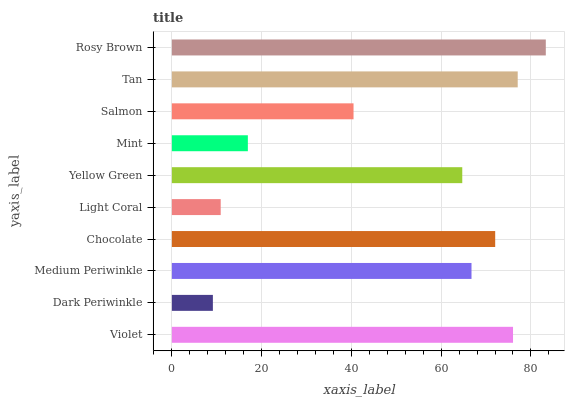Is Dark Periwinkle the minimum?
Answer yes or no. Yes. Is Rosy Brown the maximum?
Answer yes or no. Yes. Is Medium Periwinkle the minimum?
Answer yes or no. No. Is Medium Periwinkle the maximum?
Answer yes or no. No. Is Medium Periwinkle greater than Dark Periwinkle?
Answer yes or no. Yes. Is Dark Periwinkle less than Medium Periwinkle?
Answer yes or no. Yes. Is Dark Periwinkle greater than Medium Periwinkle?
Answer yes or no. No. Is Medium Periwinkle less than Dark Periwinkle?
Answer yes or no. No. Is Medium Periwinkle the high median?
Answer yes or no. Yes. Is Yellow Green the low median?
Answer yes or no. Yes. Is Chocolate the high median?
Answer yes or no. No. Is Violet the low median?
Answer yes or no. No. 